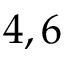<formula> <loc_0><loc_0><loc_500><loc_500>4 , 6</formula> 